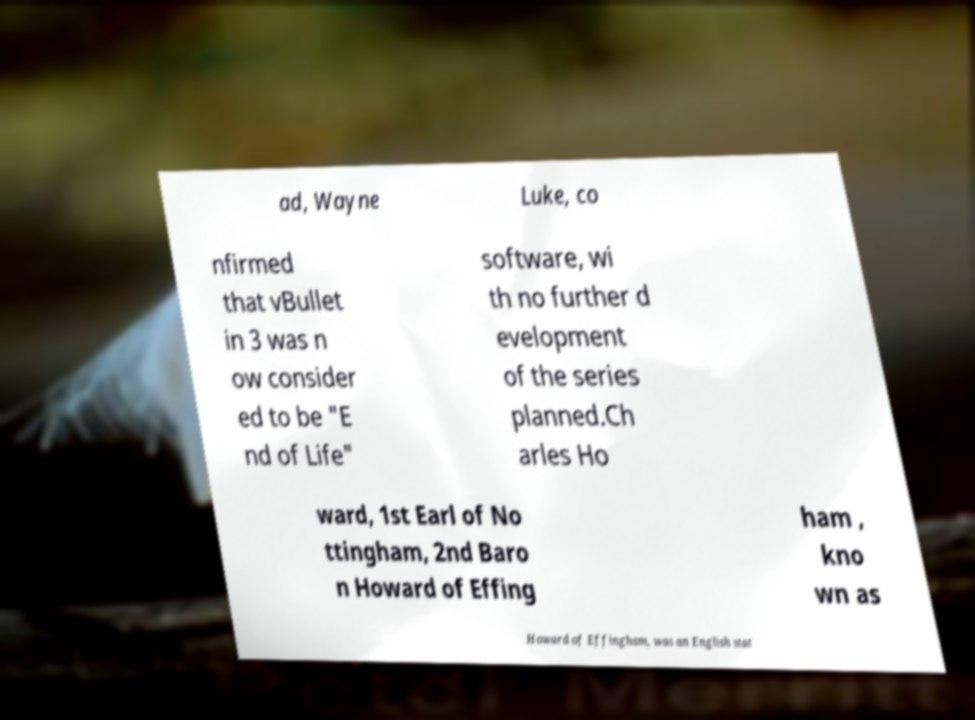What messages or text are displayed in this image? I need them in a readable, typed format. ad, Wayne Luke, co nfirmed that vBullet in 3 was n ow consider ed to be "E nd of Life" software, wi th no further d evelopment of the series planned.Ch arles Ho ward, 1st Earl of No ttingham, 2nd Baro n Howard of Effing ham , kno wn as Howard of Effingham, was an English stat 